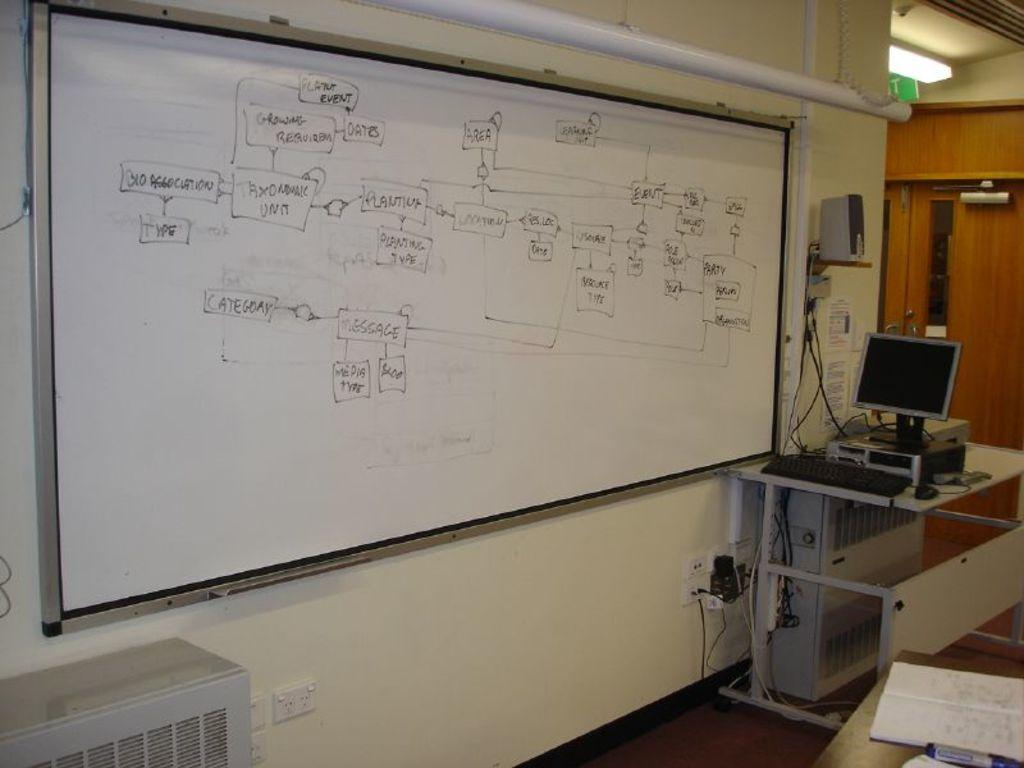What is the main object in the image? There is a white color board in the image. What electronic device is located at the right side of the image? There is a monitor at the right side of the image. What is used for typing on the computer in the image? There is a keyboard on the table in the image. What device is used for producing sound in the image? There is a speaker in the image. What can be seen in the background of the image? There is a wall in the background of the image. How many apples are on the color board in the image? There are no apples present on the color board in the image. What type of operation is being performed on the computer in the image? There is no indication of any operation being performed on the computer in the image. 